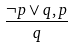Convert formula to latex. <formula><loc_0><loc_0><loc_500><loc_500>\frac { \neg p \vee q , p } { q }</formula> 